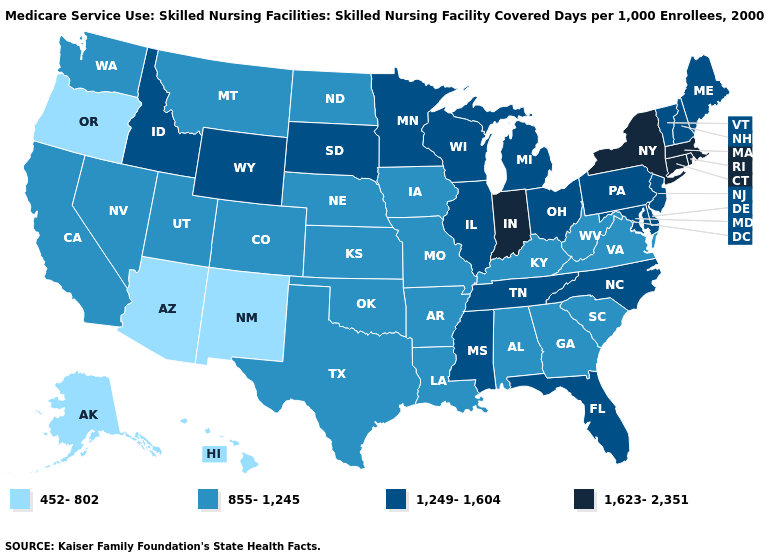Which states have the lowest value in the MidWest?
Short answer required. Iowa, Kansas, Missouri, Nebraska, North Dakota. What is the value of Michigan?
Concise answer only. 1,249-1,604. Among the states that border Tennessee , does North Carolina have the lowest value?
Be succinct. No. What is the lowest value in the USA?
Concise answer only. 452-802. Name the states that have a value in the range 855-1,245?
Be succinct. Alabama, Arkansas, California, Colorado, Georgia, Iowa, Kansas, Kentucky, Louisiana, Missouri, Montana, Nebraska, Nevada, North Dakota, Oklahoma, South Carolina, Texas, Utah, Virginia, Washington, West Virginia. What is the lowest value in the USA?
Give a very brief answer. 452-802. What is the value of Wisconsin?
Quick response, please. 1,249-1,604. Does Oregon have the lowest value in the USA?
Quick response, please. Yes. Name the states that have a value in the range 1,249-1,604?
Concise answer only. Delaware, Florida, Idaho, Illinois, Maine, Maryland, Michigan, Minnesota, Mississippi, New Hampshire, New Jersey, North Carolina, Ohio, Pennsylvania, South Dakota, Tennessee, Vermont, Wisconsin, Wyoming. Which states have the lowest value in the South?
Be succinct. Alabama, Arkansas, Georgia, Kentucky, Louisiana, Oklahoma, South Carolina, Texas, Virginia, West Virginia. Does the map have missing data?
Short answer required. No. Name the states that have a value in the range 1,623-2,351?
Quick response, please. Connecticut, Indiana, Massachusetts, New York, Rhode Island. Does Louisiana have a higher value than Idaho?
Be succinct. No. What is the lowest value in the Northeast?
Concise answer only. 1,249-1,604. Name the states that have a value in the range 452-802?
Keep it brief. Alaska, Arizona, Hawaii, New Mexico, Oregon. 